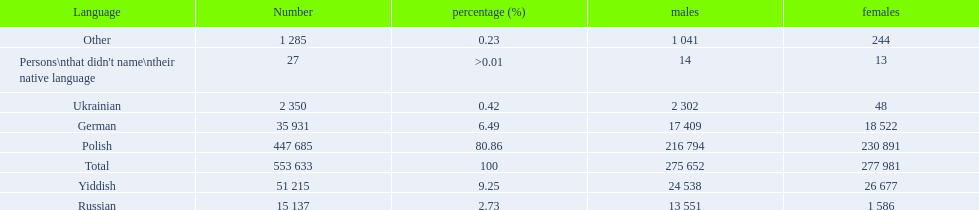Which language options are listed? Polish, Yiddish, German, Russian, Ukrainian, Other, Persons\nthat didn't name\ntheir native language. Of these, which did .42% of the people select? Ukrainian. 